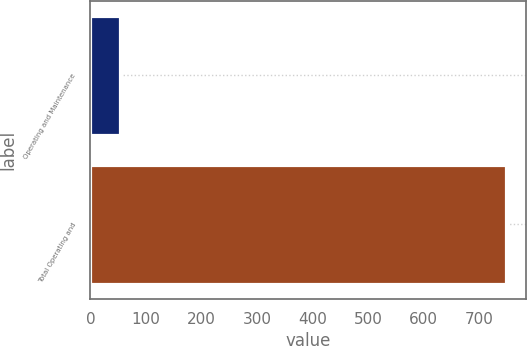Convert chart. <chart><loc_0><loc_0><loc_500><loc_500><bar_chart><fcel>Operating and Maintenance<fcel>Total Operating and<nl><fcel>53<fcel>748<nl></chart> 